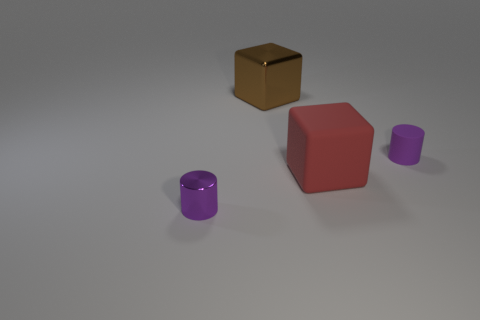Imagine these objects are part of a set, what could be the purpose of this set? If these objects are part of a set, they could serve an educational purpose, such as teaching about geometrical shapes and colors. They may also be used in a cognitive psychology experiment to study perception or for an art installation that explores the interplay between color, shape, and material. 